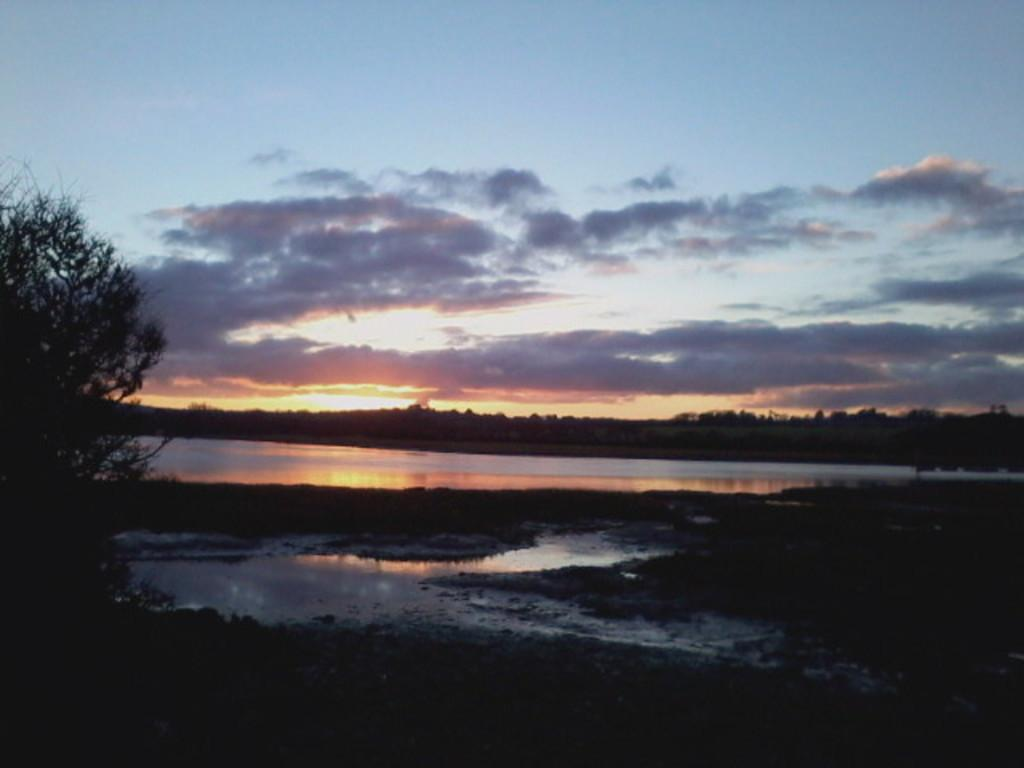At what time of day was the image taken? The image was taken during the evening time. What type of natural environment can be seen in the image? There are trees and water visible in the image. What is visible in the sky in the image? The sky is visible in the image, and clouds are present. Can the sun be seen in the image? Yes, the sun is visible in the image. What type of writing can be seen on the trees in the image? There is no writing visible on the trees in the image. Can you tell me how many campers are present in the image? There is no reference to campers or a camp in the image. 